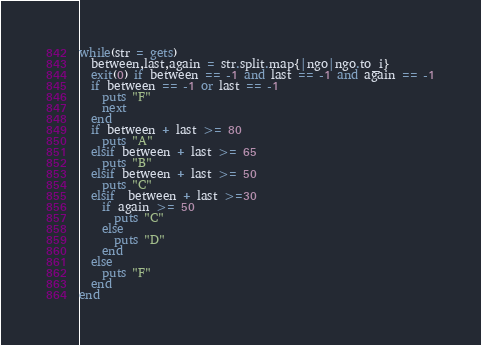Convert code to text. <code><loc_0><loc_0><loc_500><loc_500><_Ruby_>while(str = gets)
  between,last,again = str.split.map{|ngo|ngo.to_i}
  exit(0) if between == -1 and last == -1 and again == -1
  if between == -1 or last == -1
    puts "F"
    next
  end
  if between + last >= 80
    puts "A"
  elsif between + last >= 65
    puts "B"
  elsif between + last >= 50
    puts "C"
  elsif  between + last >=30
    if again >= 50
      puts "C"
    else
      puts "D"
    end
  else
    puts "F"
  end
end
</code> 